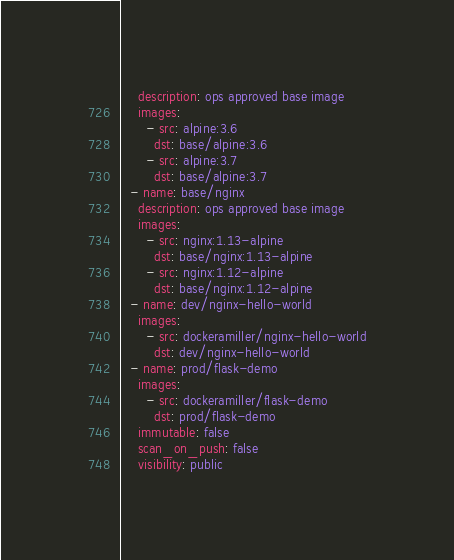Convert code to text. <code><loc_0><loc_0><loc_500><loc_500><_YAML_>    description: ops approved base image
    images:
      - src: alpine:3.6
        dst: base/alpine:3.6
      - src: alpine:3.7
        dst: base/alpine:3.7
  - name: base/nginx
    description: ops approved base image
    images:
      - src: nginx:1.13-alpine
        dst: base/nginx:1.13-alpine
      - src: nginx:1.12-alpine
        dst: base/nginx:1.12-alpine
  - name: dev/nginx-hello-world
    images:
      - src: dockeramiller/nginx-hello-world
        dst: dev/nginx-hello-world
  - name: prod/flask-demo
    images:
      - src: dockeramiller/flask-demo
        dst: prod/flask-demo
    immutable: false
    scan_on_push: false
    visibility: public
</code> 